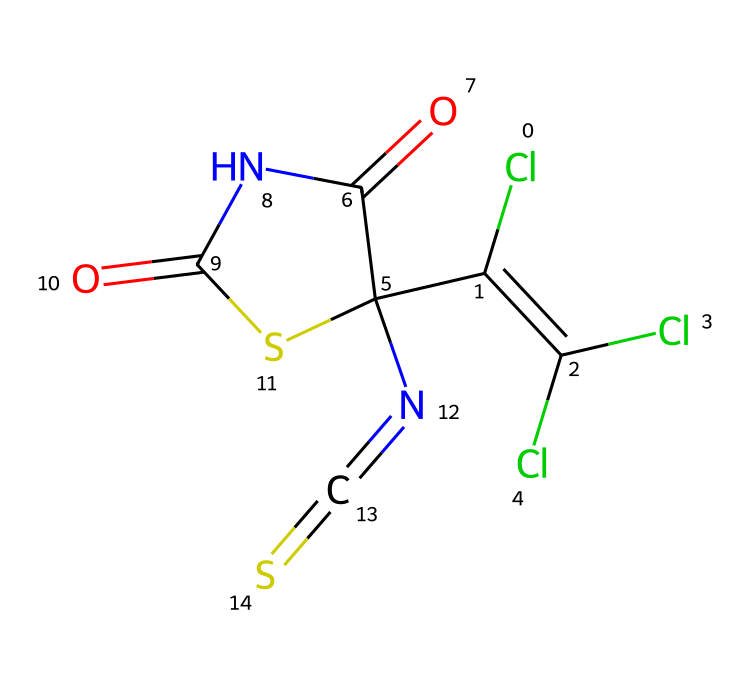What is the overall molecular formula of captan? To determine the molecular formula, we can break down the SMILES representation. By counting each type of atom present, we find: 10 Carbon (C), 8 Hydrogen (H), 1 Nitrogen (N), 4 Oxygen (O), and 2 Chlorine (Cl) atoms. Thus, the overall molecular formula is C10H8Cl2N2O4S.
Answer: C10H8Cl2N2O4S How many rings are present in this structure? By observing the SMILES structure, we look for the 'C1' which indicates the start of a ring and its corresponding closing partner. It's found that there is one cyclic structure or ring present in the chemical, formed with the notation.
Answer: 1 What functional groups can be identified in captan? By analyzing the SMILES and understanding common functional groups, we can identify a phthalimide and a thiocarbonyl group based on specific elements (e.g., the presence of 'N' for nitrogen and 'S' for sulfur).
Answer: phthalimide, thiocarbonyl What is the total number of nitrogen atoms in the structure? In the SMILES, 'N' indicates the presence of nitrogen atoms. By scanning the entire representation, we find there are two nitrogen atoms represented in the structure.
Answer: 2 What is the significance of the chlorine atoms in this fungicide? The presence of chlorine in the chemical structure indicates that it is a chlorinated compound, which often imparts specific biological activity related to its fungicidal properties. Chlorine atoms typically play a role in enhancing the efficacy of fungicides.
Answer: biological activity How does the presence of sulfur affect the properties of captan? Sulfur, indicated by 'S' in the SMILES, is crucial for the fungicidal activity of the compound, as it can alter biological interactions with fungal target sites. It often enhances the fungicide's effectiveness through its unique properties.
Answer: effectiveness of fungicide 